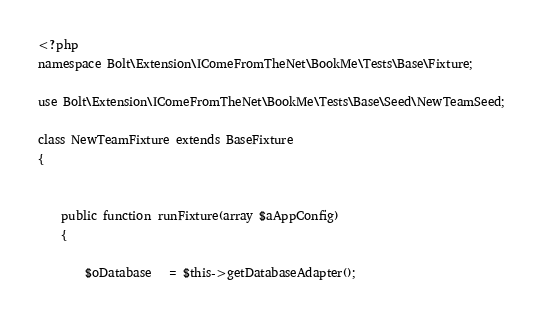<code> <loc_0><loc_0><loc_500><loc_500><_PHP_><?php
namespace Bolt\Extension\IComeFromTheNet\BookMe\Tests\Base\Fixture;

use Bolt\Extension\IComeFromTheNet\BookMe\Tests\Base\Seed\NewTeamSeed;

class NewTeamFixture extends BaseFixture
{
 
    
    public function runFixture(array $aAppConfig)
    {
      
        $oDatabase   = $this->getDatabaseAdapter();</code> 